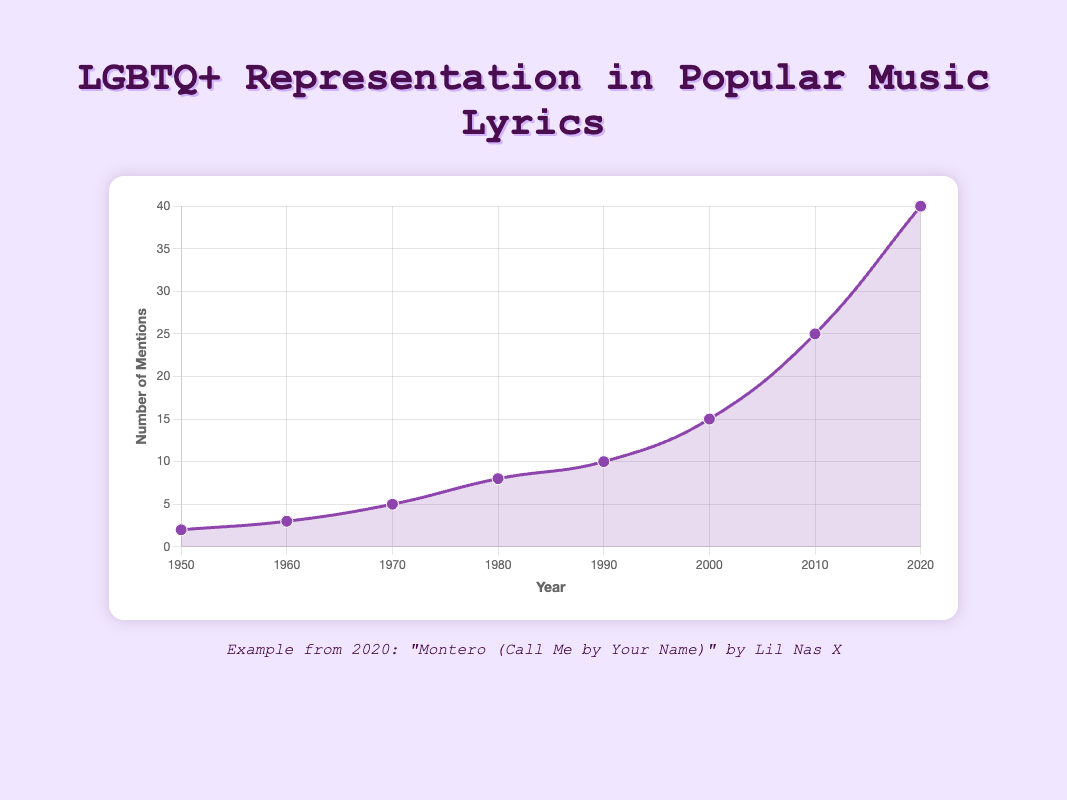What is the overall trend in LGBTQ+ mentions in popular music lyrics from 1950 to 2020? The figure shows an increasing trend in LGBTQ+ mentions in popular music lyrics over time. Each decade demonstrates a rise in the number of mentions, from 2 in 1950 to 40 in 2020.
Answer: Increasing trend How many mentions were there in 1980 and how does it compare to 1990? The mentions in 1980 were 8. In 1990, the mentions increased to 10, indicating a rise of 2 mentions between these years.
Answer: 8 in 1980; 2 more in 1990 Which decade saw the largest increase in LGBTQ+ mentions in music lyrics? Calculating the differences between each decade: 1950-60: 1, 1960-70: 2, 1970-80: 3, 1980-90: 2, 1990-2000: 5, 2000-10: 10, 2010-20: 15. The largest increase occurred between 2010 and 2020 with an increase of 15 mentions.
Answer: 2010-2020 How many mentions of LGBTQ+ terms were there in the 1970s? The figure shows 5 mentions in 1970. With no other data points within the decade, this is the total number of mentions for the 1970s.
Answer: 5 mentions What is the median number of mentions from 1950 to 2020? Listing the mentions: 2, 3, 5, 8, 10, 15, 25, 40. To find the median, we order these values and find the middle value(s). Since there are 8 values, the median is the average of the 4th and 5th values, (8 + 10)/2 = 9.
Answer: 9 What is the percentage increase in LGBTQ+ mentions from 2000 to 2020? The mentions in 2000 were 15 and in 2020 were 40. The percentage increase is calculated as ((40 - 15) / 15) * 100 = 166.67%.
Answer: 166.67% Which year had the highest number of LGBTQ+ mentions in music lyrics? According to the figure, the year 2020 had the highest number of LGBTQ+ mentions with 40 mentions.
Answer: 2020 How does the number of LGBTQ+ mentions in 1960 compare to 2010? In 1960, there were 3 mentions, whereas in 2010, there were 25 mentions. This is an increase of 22 mentions between these years.
Answer: 22 more in 2010 